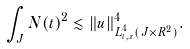Convert formula to latex. <formula><loc_0><loc_0><loc_500><loc_500>\int _ { J } N ( t ) ^ { 2 } \lesssim \| u \| _ { L _ { t , x } ^ { 4 } ( J \times R ^ { 2 } ) } ^ { 4 } .</formula> 